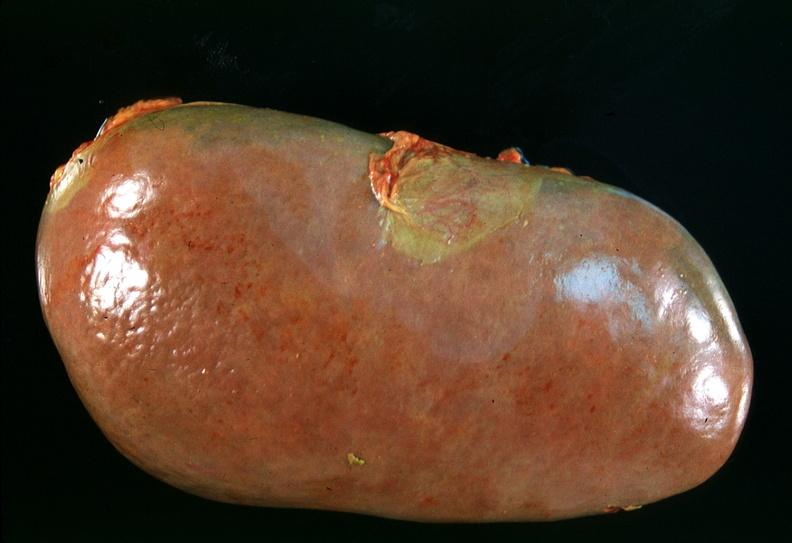why does this image show spleen, chronic congestion?
Answer the question using a single word or phrase. Due to portal hypertension from cirrhosis hcv 